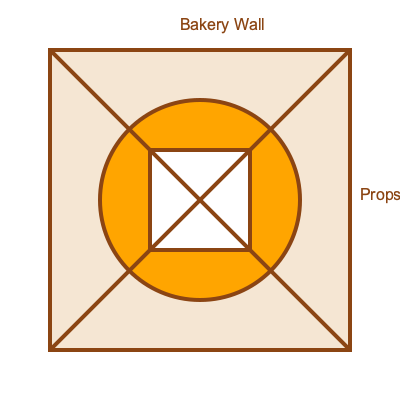Based on the diagram, which geometric shape arrangement would create the most visually appealing and Instagram-worthy photo spot for your bakery? Consider the principles of symmetry, contrast, and visual interest. To determine the most visually appealing and Instagram-worthy photo spot, let's analyze the geometric shapes in the diagram:

1. Background: The large rectangle represents the bakery wall, providing a neutral backdrop.

2. Focal point: The circle in the center creates a strong focal point, drawing the eye to the middle of the composition.

3. Framing: The smaller square within the circle adds depth and creates a frame-within-frame effect.

4. Dynamic lines: The diagonal lines crossing the entire composition add energy and movement to the design.

5. Contrast: The different shapes (rectangle, circle, square) and their varying sizes create visual contrast.

6. Symmetry: The overall composition is symmetrical, with the circle and square centered within the rectangle.

7. Golden ratio: The circular shape approximates the golden ratio, which is aesthetically pleasing to the human eye.

8. Layering: The overlapping shapes create a sense of depth and dimension.

9. Negative space: The areas between shapes allow for visual breathing room and balance.

10. Versatility: This arrangement allows for easy customization with props, seasonal decorations, or product displays.

Given these elements, this geometric arrangement creates a visually appealing and Instagram-worthy photo spot by incorporating principles of design such as balance, contrast, focal point, and visual interest. The circular shape serves as an ideal frame for customers to pose within, while the overall composition provides an eye-catching background that's easily recognizable and shareable on social media platforms like Instagram.
Answer: The circular focal point with square inset, centered on the wall with diagonal lines 